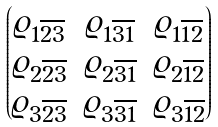<formula> <loc_0><loc_0><loc_500><loc_500>\begin{pmatrix} \varrho _ { 1 \overline { 2 } \overline { 3 } } & \varrho _ { 1 \overline { 3 } \overline { 1 } } & \varrho _ { 1 \overline { 1 } \overline { 2 } } \\ \varrho _ { 2 \overline { 2 } \overline { 3 } } & \varrho _ { 2 \overline { 3 } \overline { 1 } } & \varrho _ { 2 \overline { 1 } \overline { 2 } } \\ \varrho _ { 3 \overline { 2 } \overline { 3 } } & \varrho _ { 3 \overline { 3 } \overline { 1 } } & \varrho _ { 3 \overline { 1 } \overline { 2 } } \end{pmatrix}</formula> 